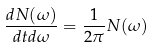Convert formula to latex. <formula><loc_0><loc_0><loc_500><loc_500>\frac { d N ( \omega ) } { d t d \omega } = \frac { 1 } { 2 \pi } N ( \omega )</formula> 